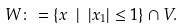Convert formula to latex. <formula><loc_0><loc_0><loc_500><loc_500>W \colon = \{ x \ | \ | x _ { 1 } | \leq 1 \} \cap V .</formula> 